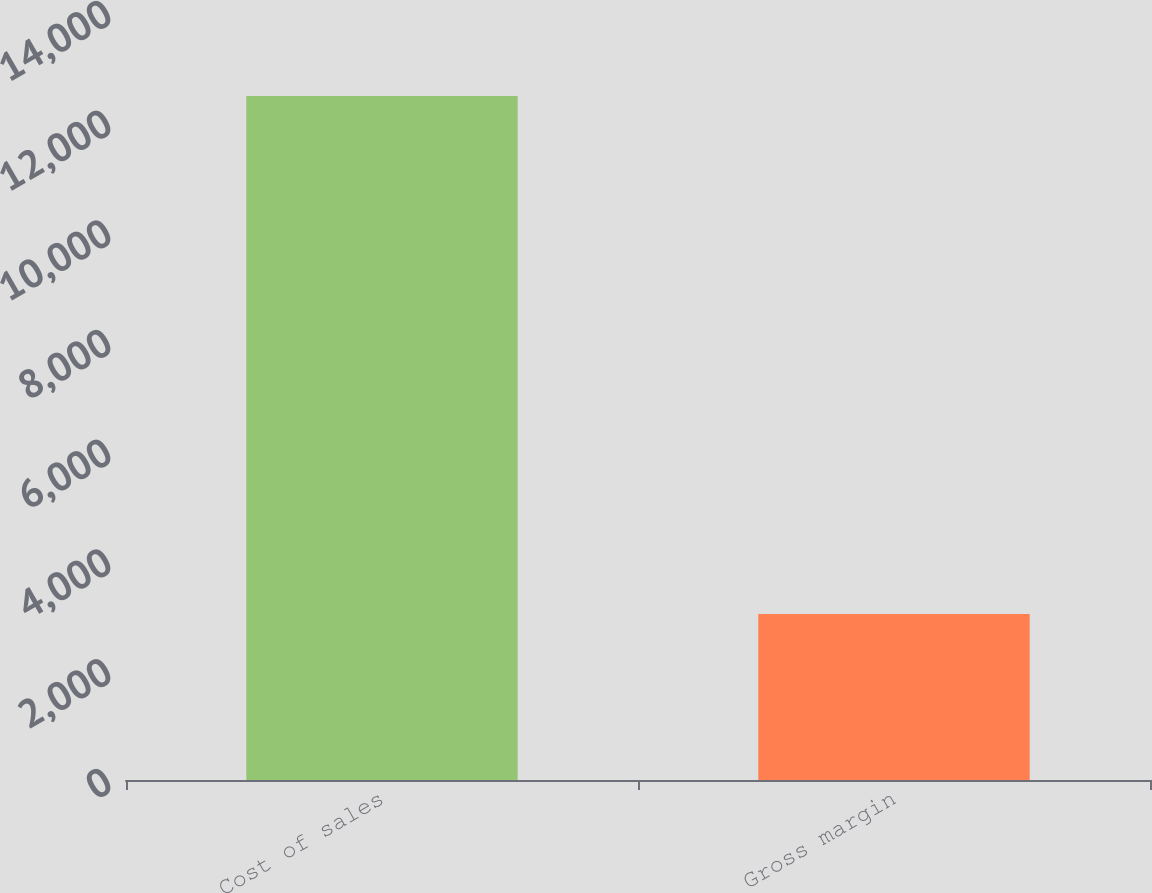Convert chart to OTSL. <chart><loc_0><loc_0><loc_500><loc_500><bar_chart><fcel>Cost of sales<fcel>Gross margin<nl><fcel>12471<fcel>3028<nl></chart> 